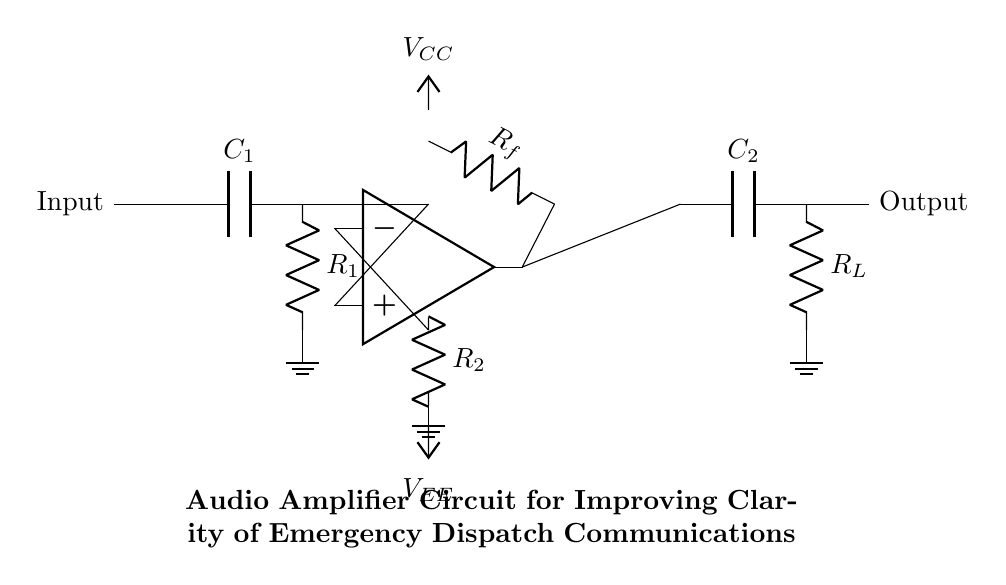What is the type of the amplifier used in this circuit? The circuit diagram shows an operational amplifier, which is a common type of amplifier used for various applications including audio signal amplification. The op amp is labeled specifically in the diagram.
Answer: operational amplifier What component is used for coupling the input signal? The diagram indicates a capacitor labeled C1 connected to the input, which serves to couple the input signal while blocking any DC offset. This is a typical practice to ensure the amplifier only processes the AC components of the signal.
Answer: capacitor What is the purpose of the feedback resistor labeled Rf? The feedback resistor Rf is connected from the output back to the inverting input of the operational amplifier. Its main purpose is to control the gain of the amplifier, thereby allowing for a clearer and amplified output signal from the input which is critical in dispatch communications.
Answer: gain control What are the supply voltages shown in the circuit? The circuit specifies two supply voltages: VCC and VEE. VCC is typically the positive supply voltage while VEE is the negative supply voltage, providing the necessary power for the op amp to function properly and amplify the input signal.
Answer: VCC and VEE What is the output arrangement in this audio amplifier circuit? The output stage includes a capacitor labeled C2 which helps in decoupling the amplified audio signal and preventing any DC component from reaching the load resistor RL. This arrangement is vital for ensuring that only the AC signal is passed on to the next stage or output device.
Answer: load resistor RL What does component R2 do in the circuit? The resistor R2 is connected to the inverting input of the op amp. It helps set the gain configuration by forming a part of the feedback loop with Rf, impacting the stability and gain of the amplified signal.
Answer: sets gain configuration 